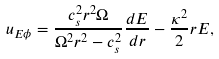<formula> <loc_0><loc_0><loc_500><loc_500>u _ { E \phi } = \frac { c _ { s } ^ { 2 } r ^ { 2 } \Omega } { \Omega ^ { 2 } r ^ { 2 } - c _ { s } ^ { 2 } } \frac { d E } { d r } - \frac { \kappa ^ { 2 } } { 2 } r E ,</formula> 